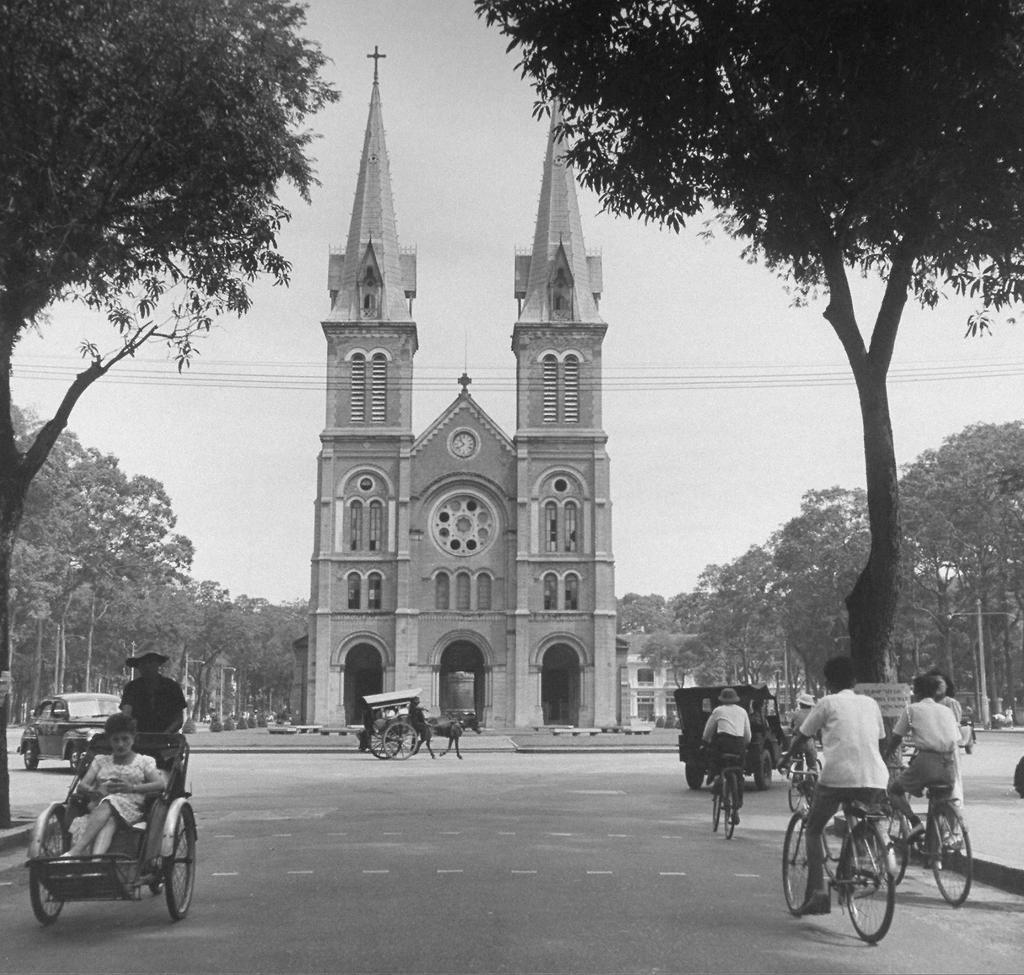Can you describe this image briefly? In the center of the image we can see a building and there are vehicles on the road. There is a horse cart. In the background there are trees, wires and sky. 